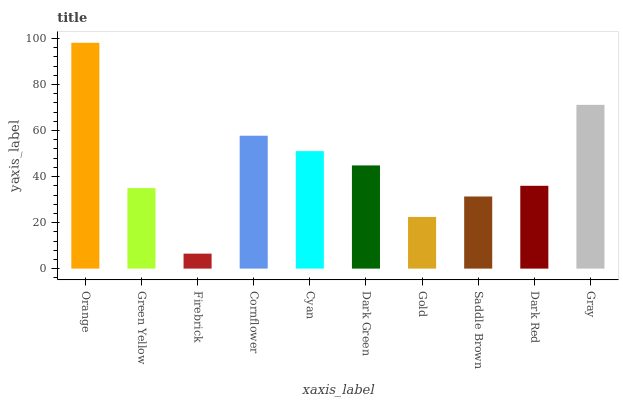Is Firebrick the minimum?
Answer yes or no. Yes. Is Orange the maximum?
Answer yes or no. Yes. Is Green Yellow the minimum?
Answer yes or no. No. Is Green Yellow the maximum?
Answer yes or no. No. Is Orange greater than Green Yellow?
Answer yes or no. Yes. Is Green Yellow less than Orange?
Answer yes or no. Yes. Is Green Yellow greater than Orange?
Answer yes or no. No. Is Orange less than Green Yellow?
Answer yes or no. No. Is Dark Green the high median?
Answer yes or no. Yes. Is Dark Red the low median?
Answer yes or no. Yes. Is Green Yellow the high median?
Answer yes or no. No. Is Gold the low median?
Answer yes or no. No. 